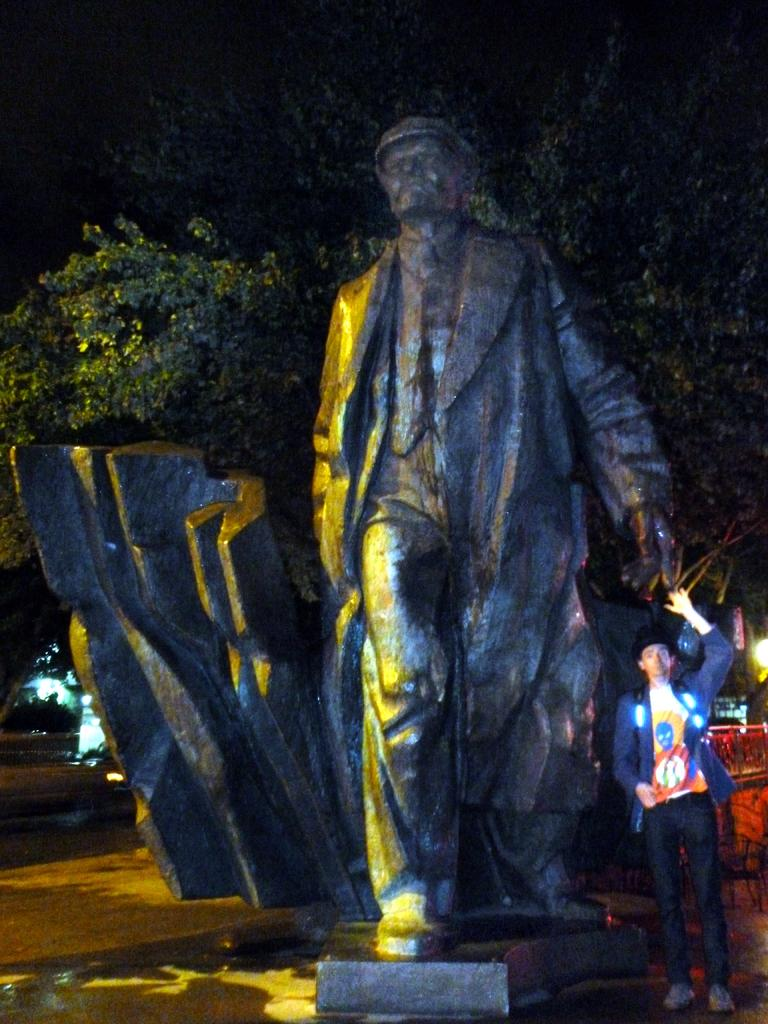What is the main subject in the middle of the picture? There is a statue of a human in the middle of the picture. Can you describe the person on the right side of the picture? There is a person standing on the right side of the picture. What can be seen in the background of the picture? There are trees in the background of the picture. How many dogs are pulling the statue in the image? There are no dogs present in the image, and therefore no dogs are pulling the statue. 